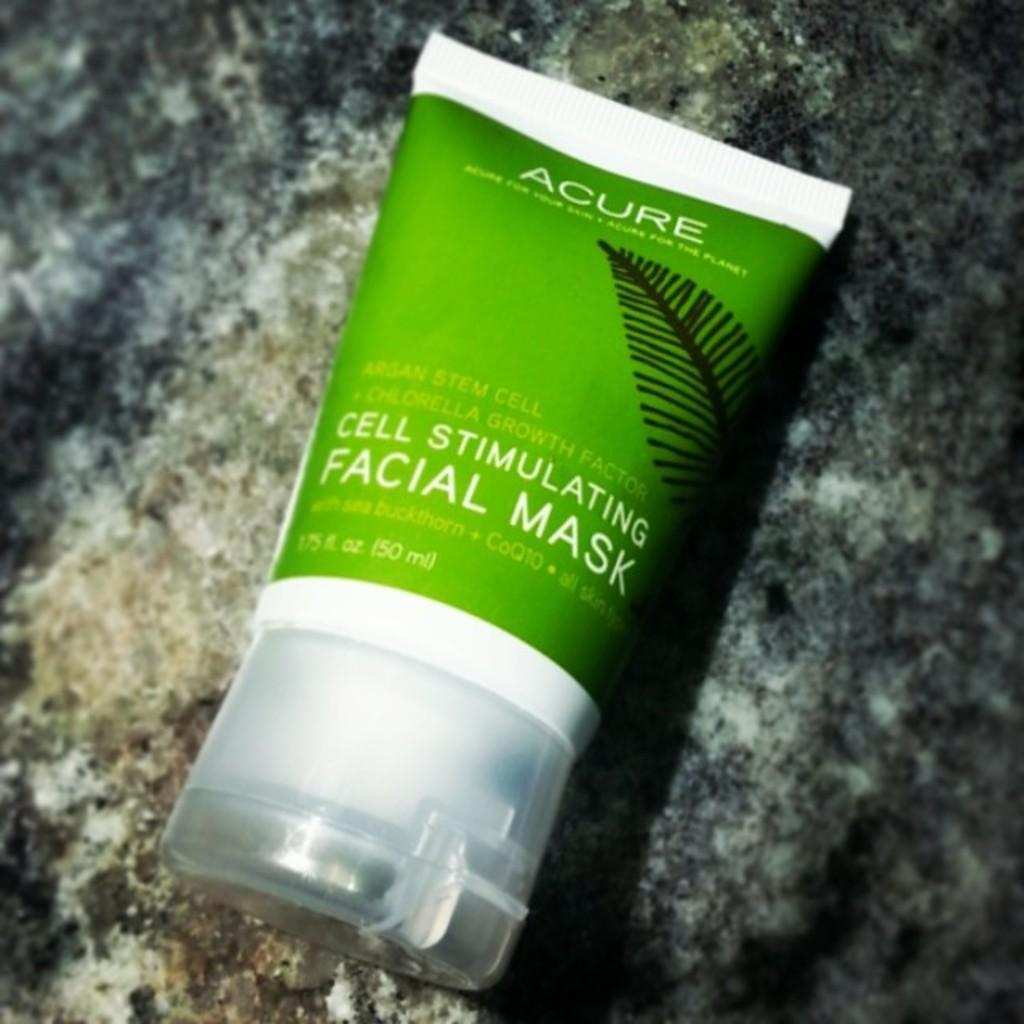What object is featured in the picture? There is a cosmetic tube in the picture. What design is on the cosmetic tube? The tube has a picture of a leaf on it. What else can be found on the cosmetic tube? There is text on the tube. How many people are attending the party in the image? There is no party depicted in the image; it features a cosmetic tube with a leaf design and text. What type of grass is growing in the image? There is no grass present in the image; it features a cosmetic tube with a leaf design and text. 